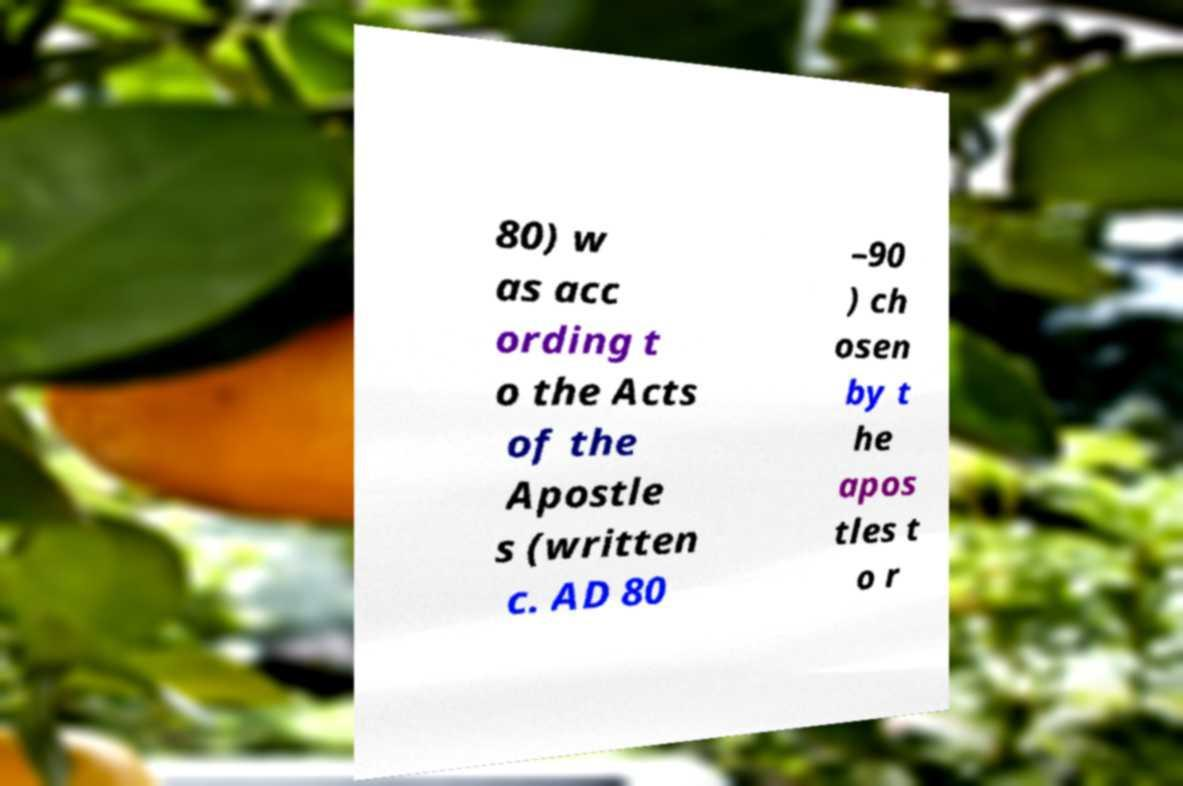I need the written content from this picture converted into text. Can you do that? 80) w as acc ording t o the Acts of the Apostle s (written c. AD 80 –90 ) ch osen by t he apos tles t o r 